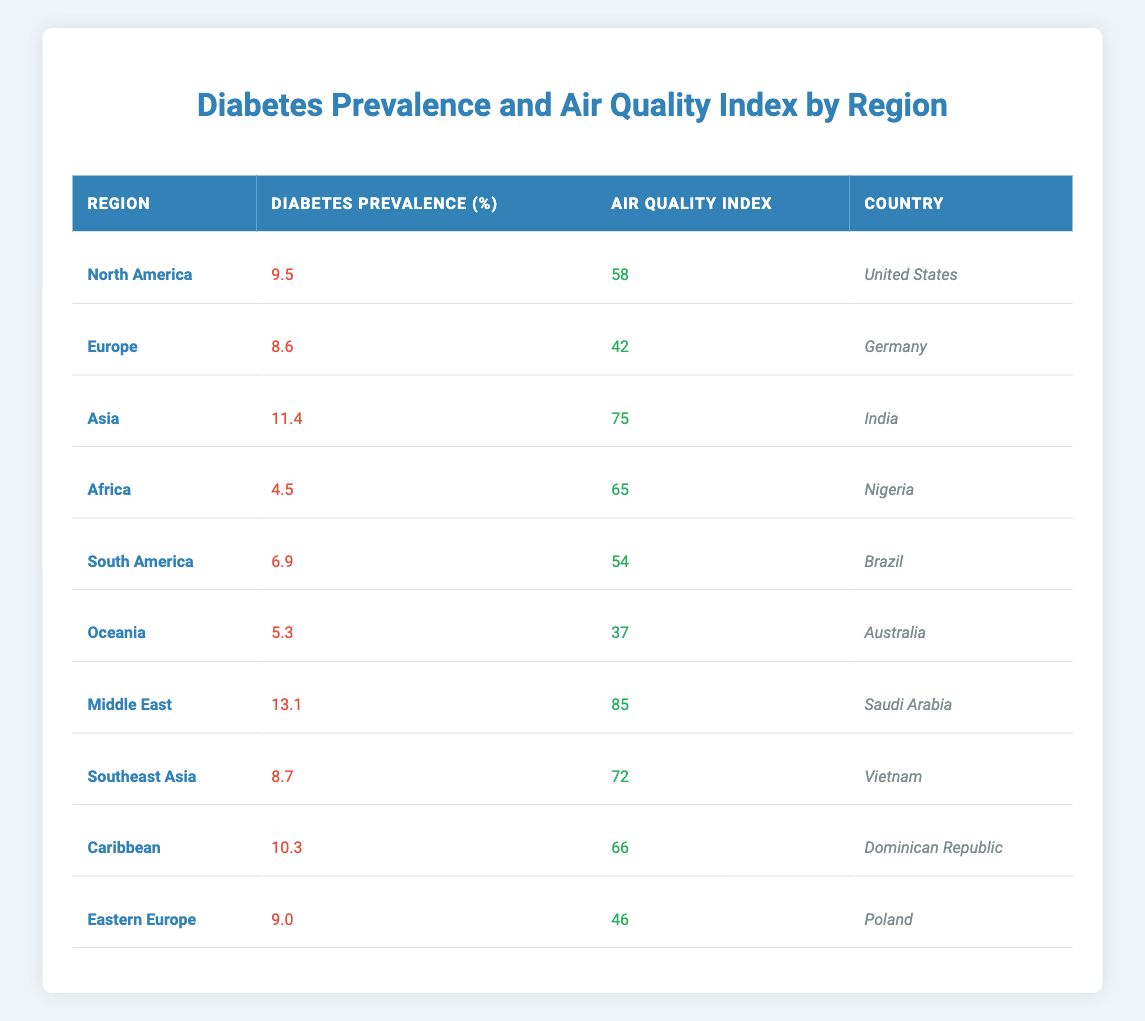What is the diabetes prevalence in Asia? The table provides the diabetes prevalence for Asia as listed directly under the "Diabetes Prevalence (%)" column, which shows a value of 11.4%.
Answer: 11.4% Which region has the lowest air quality index? By examining the "Air Quality Index" column, we see that Oceania has the lowest value of 37 among all the regions listed.
Answer: Oceania What is the diabetes prevalence difference between the Middle East and Africa? The diabetes prevalence for the Middle East is 13.1% and for Africa, it is 4.5%. The difference is calculated by subtracting Africa's prevalence from the Middle East's: 13.1% - 4.5% = 8.6%.
Answer: 8.6% Is the diabetes prevalence in North America higher than that in Europe? The table indicates a diabetes prevalence of 9.5% for North America and 8.6% for Europe. Since 9.5% is greater than 8.6%, the statement is true.
Answer: Yes What is the average diabetes prevalence across all regions shown in the table? The individual diabetes prevalence values are 9.5, 8.6, 11.4, 4.5, 6.9, 5.3, 13.1, 8.7, 10.3, and 9.0%. We add these values (9.5 + 8.6 + 11.4 + 4.5 + 6.9 + 5.3 + 13.1 + 8.7 + 10.3 + 9.0 = 77.3) and divide by the number of regions (10): 77.3 / 10 = 7.73%.
Answer: 7.73% Which region has the highest diabetes prevalence and what is its air quality index? The highest diabetes prevalence is found in the Middle East at 13.1%. The corresponding air quality index for this region is 85.
Answer: Middle East, 85 What is the air quality index of the region with the lowest diabetes prevalence? Africa has the lowest diabetes prevalence at 4.5%. Looking at the "Air Quality Index", Africa's air quality index is 65.
Answer: 65 Is it true that all regions with higher diabetes prevalence have correspondingly higher air quality indices? By comparing the values, we see that while the Middle East (13.1%, 85) and Asia (11.4%, 75) follow this trend, Oceania (5.3%, 37) and Africa (4.5%, 65) have lower diabetes prevalence yet Oceania has the lowest air quality index. Therefore, the statement is false.
Answer: No What are the diabetes prevalence values for North America, Europe, and South America? North America has a prevalence of 9.5%, Europe has 8.6%, and South America has 6.9%. Listing these together gives the answer.
Answer: 9.5%, 8.6%, 6.9% How does the air quality index of Southeast Asia compare to that of North America? Southeast Asia has an air quality index of 72, while North America has an air quality index of 58. Since 72 is greater than 58, Southeast Asia has a higher air quality index.
Answer: Higher Calculate the difference in air quality index between the highest and lowest values. The highest air quality index is in the Middle East at 85, and the lowest is in Oceania at 37. The difference is calculated as 85 - 37 = 48.
Answer: 48 